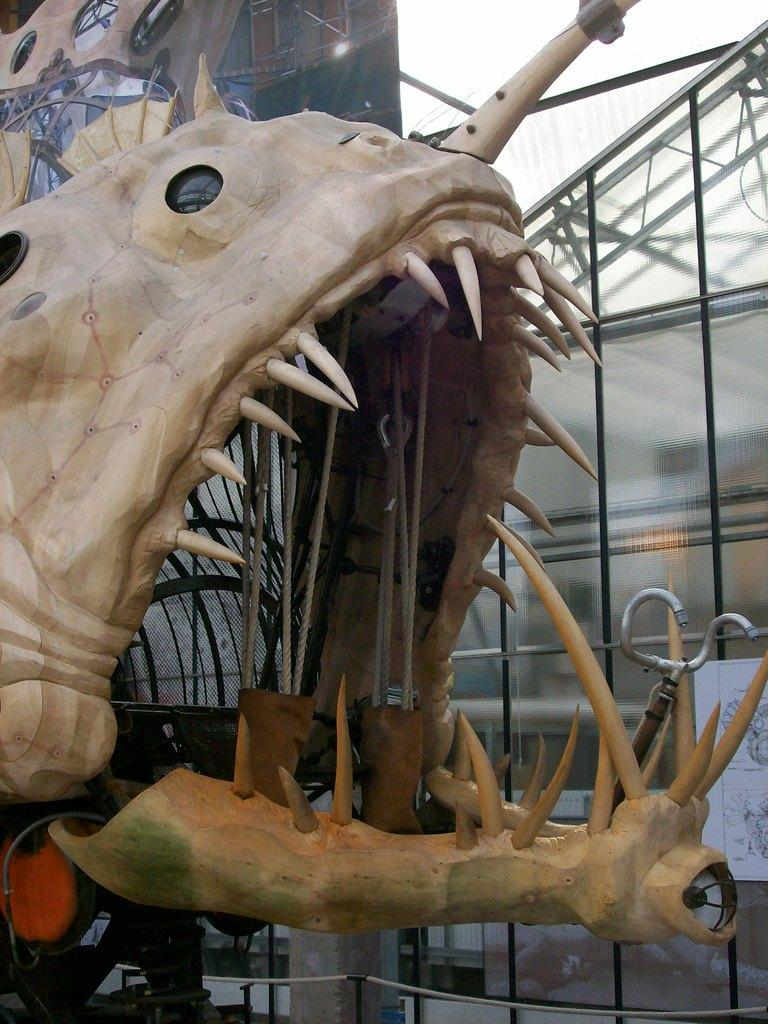What is the main subject of the picture? The main subject of the picture is an animal skull. What can be seen in the background of the picture? There is an iron frame in the background of the picture. What is the condition of the sky in the picture? The sky is clear in the picture. What type of throne is depicted in the image? There is no throne present in the image; it features an animal skull and an iron frame in the background. What is the rate of the glue drying in the image? There is no glue present in the image, so it's not possible to determine the rate of drying. 